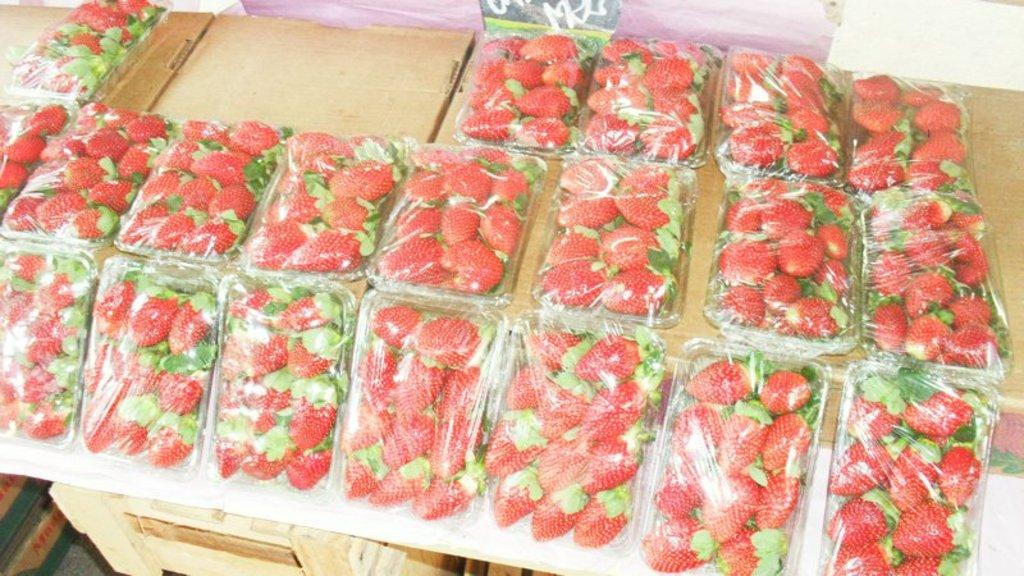What type of fruit is arranged in the boxes in the image? There are strawberries arranged in boxes in the image. What material are the boxes made of? The boxes are made of wood. What color is the crayon in the image? There is no crayon present in the image. What is the weather like in the image? The provided facts do not mention any information about the weather, so we cannot determine the weather from the image. 